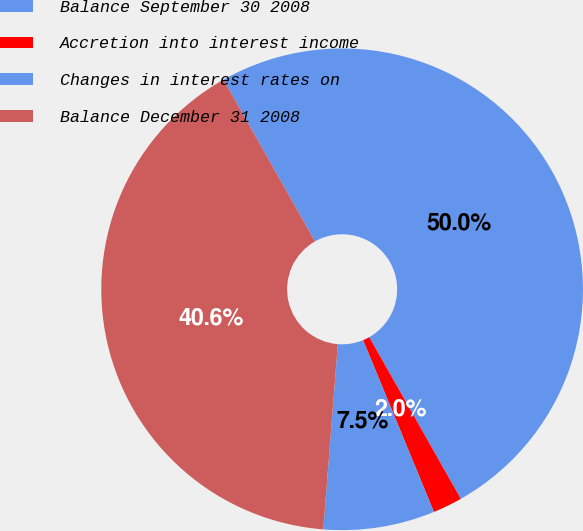<chart> <loc_0><loc_0><loc_500><loc_500><pie_chart><fcel>Balance September 30 2008<fcel>Accretion into interest income<fcel>Changes in interest rates on<fcel>Balance December 31 2008<nl><fcel>50.0%<fcel>1.98%<fcel>7.47%<fcel>40.56%<nl></chart> 